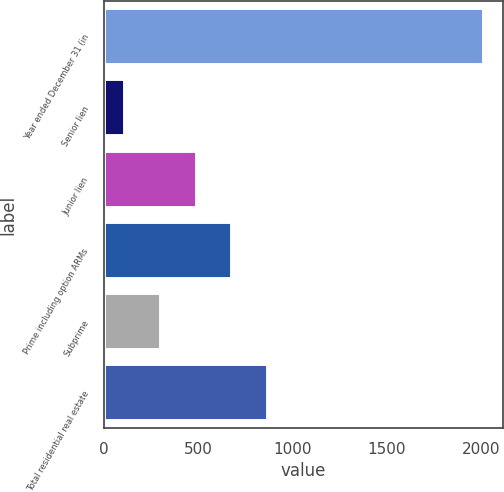<chart> <loc_0><loc_0><loc_500><loc_500><bar_chart><fcel>Year ended December 31 (in<fcel>Senior lien<fcel>Junior lien<fcel>Prime including option ARMs<fcel>Subprime<fcel>Total residential real estate<nl><fcel>2014<fcel>110<fcel>490.8<fcel>681.2<fcel>300.4<fcel>871.6<nl></chart> 